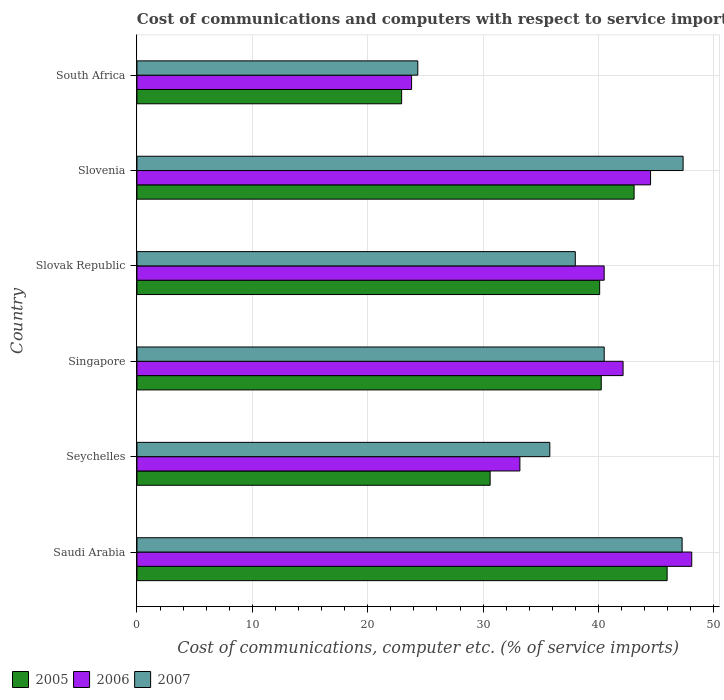How many different coloured bars are there?
Offer a very short reply. 3. What is the label of the 4th group of bars from the top?
Give a very brief answer. Singapore. In how many cases, is the number of bars for a given country not equal to the number of legend labels?
Offer a terse response. 0. What is the cost of communications and computers in 2006 in Slovak Republic?
Ensure brevity in your answer.  40.49. Across all countries, what is the maximum cost of communications and computers in 2007?
Offer a terse response. 47.33. Across all countries, what is the minimum cost of communications and computers in 2007?
Ensure brevity in your answer.  24.34. In which country was the cost of communications and computers in 2007 maximum?
Offer a terse response. Slovenia. In which country was the cost of communications and computers in 2005 minimum?
Make the answer very short. South Africa. What is the total cost of communications and computers in 2007 in the graph?
Ensure brevity in your answer.  233.18. What is the difference between the cost of communications and computers in 2005 in Saudi Arabia and that in Slovenia?
Your answer should be very brief. 2.86. What is the difference between the cost of communications and computers in 2007 in Slovak Republic and the cost of communications and computers in 2005 in Slovenia?
Ensure brevity in your answer.  -5.1. What is the average cost of communications and computers in 2006 per country?
Provide a short and direct response. 38.7. What is the difference between the cost of communications and computers in 2007 and cost of communications and computers in 2005 in South Africa?
Give a very brief answer. 1.4. What is the ratio of the cost of communications and computers in 2006 in Seychelles to that in Slovenia?
Provide a succinct answer. 0.75. Is the cost of communications and computers in 2007 in Singapore less than that in Slovak Republic?
Give a very brief answer. No. Is the difference between the cost of communications and computers in 2007 in Singapore and South Africa greater than the difference between the cost of communications and computers in 2005 in Singapore and South Africa?
Offer a very short reply. No. What is the difference between the highest and the second highest cost of communications and computers in 2005?
Your answer should be compact. 2.86. What is the difference between the highest and the lowest cost of communications and computers in 2005?
Keep it short and to the point. 23.01. What does the 3rd bar from the bottom in Slovenia represents?
Your answer should be very brief. 2007. Is it the case that in every country, the sum of the cost of communications and computers in 2007 and cost of communications and computers in 2006 is greater than the cost of communications and computers in 2005?
Your answer should be compact. Yes. Are all the bars in the graph horizontal?
Give a very brief answer. Yes. What is the difference between two consecutive major ticks on the X-axis?
Your answer should be compact. 10. Are the values on the major ticks of X-axis written in scientific E-notation?
Offer a terse response. No. Does the graph contain any zero values?
Offer a terse response. No. Does the graph contain grids?
Ensure brevity in your answer.  Yes. How many legend labels are there?
Keep it short and to the point. 3. How are the legend labels stacked?
Your response must be concise. Horizontal. What is the title of the graph?
Provide a short and direct response. Cost of communications and computers with respect to service imports. Does "1991" appear as one of the legend labels in the graph?
Keep it short and to the point. No. What is the label or title of the X-axis?
Offer a terse response. Cost of communications, computer etc. (% of service imports). What is the label or title of the Y-axis?
Give a very brief answer. Country. What is the Cost of communications, computer etc. (% of service imports) of 2005 in Saudi Arabia?
Give a very brief answer. 45.95. What is the Cost of communications, computer etc. (% of service imports) in 2006 in Saudi Arabia?
Make the answer very short. 48.08. What is the Cost of communications, computer etc. (% of service imports) of 2007 in Saudi Arabia?
Ensure brevity in your answer.  47.25. What is the Cost of communications, computer etc. (% of service imports) of 2005 in Seychelles?
Your answer should be compact. 30.61. What is the Cost of communications, computer etc. (% of service imports) of 2006 in Seychelles?
Provide a short and direct response. 33.19. What is the Cost of communications, computer etc. (% of service imports) of 2007 in Seychelles?
Your answer should be very brief. 35.78. What is the Cost of communications, computer etc. (% of service imports) of 2005 in Singapore?
Your answer should be very brief. 40.24. What is the Cost of communications, computer etc. (% of service imports) in 2006 in Singapore?
Keep it short and to the point. 42.13. What is the Cost of communications, computer etc. (% of service imports) of 2007 in Singapore?
Ensure brevity in your answer.  40.49. What is the Cost of communications, computer etc. (% of service imports) of 2005 in Slovak Republic?
Keep it short and to the point. 40.1. What is the Cost of communications, computer etc. (% of service imports) in 2006 in Slovak Republic?
Provide a short and direct response. 40.49. What is the Cost of communications, computer etc. (% of service imports) in 2007 in Slovak Republic?
Keep it short and to the point. 37.99. What is the Cost of communications, computer etc. (% of service imports) in 2005 in Slovenia?
Provide a succinct answer. 43.08. What is the Cost of communications, computer etc. (% of service imports) in 2006 in Slovenia?
Give a very brief answer. 44.51. What is the Cost of communications, computer etc. (% of service imports) in 2007 in Slovenia?
Keep it short and to the point. 47.33. What is the Cost of communications, computer etc. (% of service imports) in 2005 in South Africa?
Make the answer very short. 22.94. What is the Cost of communications, computer etc. (% of service imports) of 2006 in South Africa?
Provide a succinct answer. 23.8. What is the Cost of communications, computer etc. (% of service imports) in 2007 in South Africa?
Keep it short and to the point. 24.34. Across all countries, what is the maximum Cost of communications, computer etc. (% of service imports) in 2005?
Give a very brief answer. 45.95. Across all countries, what is the maximum Cost of communications, computer etc. (% of service imports) of 2006?
Your answer should be compact. 48.08. Across all countries, what is the maximum Cost of communications, computer etc. (% of service imports) in 2007?
Your response must be concise. 47.33. Across all countries, what is the minimum Cost of communications, computer etc. (% of service imports) of 2005?
Your answer should be very brief. 22.94. Across all countries, what is the minimum Cost of communications, computer etc. (% of service imports) in 2006?
Ensure brevity in your answer.  23.8. Across all countries, what is the minimum Cost of communications, computer etc. (% of service imports) in 2007?
Provide a short and direct response. 24.34. What is the total Cost of communications, computer etc. (% of service imports) in 2005 in the graph?
Offer a very short reply. 222.92. What is the total Cost of communications, computer etc. (% of service imports) of 2006 in the graph?
Offer a very short reply. 232.2. What is the total Cost of communications, computer etc. (% of service imports) of 2007 in the graph?
Ensure brevity in your answer.  233.18. What is the difference between the Cost of communications, computer etc. (% of service imports) of 2005 in Saudi Arabia and that in Seychelles?
Ensure brevity in your answer.  15.34. What is the difference between the Cost of communications, computer etc. (% of service imports) of 2006 in Saudi Arabia and that in Seychelles?
Ensure brevity in your answer.  14.9. What is the difference between the Cost of communications, computer etc. (% of service imports) in 2007 in Saudi Arabia and that in Seychelles?
Provide a succinct answer. 11.47. What is the difference between the Cost of communications, computer etc. (% of service imports) of 2005 in Saudi Arabia and that in Singapore?
Your answer should be compact. 5.71. What is the difference between the Cost of communications, computer etc. (% of service imports) in 2006 in Saudi Arabia and that in Singapore?
Keep it short and to the point. 5.95. What is the difference between the Cost of communications, computer etc. (% of service imports) of 2007 in Saudi Arabia and that in Singapore?
Give a very brief answer. 6.75. What is the difference between the Cost of communications, computer etc. (% of service imports) in 2005 in Saudi Arabia and that in Slovak Republic?
Your response must be concise. 5.85. What is the difference between the Cost of communications, computer etc. (% of service imports) of 2006 in Saudi Arabia and that in Slovak Republic?
Your answer should be very brief. 7.59. What is the difference between the Cost of communications, computer etc. (% of service imports) of 2007 in Saudi Arabia and that in Slovak Republic?
Keep it short and to the point. 9.26. What is the difference between the Cost of communications, computer etc. (% of service imports) of 2005 in Saudi Arabia and that in Slovenia?
Give a very brief answer. 2.86. What is the difference between the Cost of communications, computer etc. (% of service imports) in 2006 in Saudi Arabia and that in Slovenia?
Your answer should be very brief. 3.57. What is the difference between the Cost of communications, computer etc. (% of service imports) of 2007 in Saudi Arabia and that in Slovenia?
Keep it short and to the point. -0.08. What is the difference between the Cost of communications, computer etc. (% of service imports) of 2005 in Saudi Arabia and that in South Africa?
Ensure brevity in your answer.  23.01. What is the difference between the Cost of communications, computer etc. (% of service imports) in 2006 in Saudi Arabia and that in South Africa?
Keep it short and to the point. 24.28. What is the difference between the Cost of communications, computer etc. (% of service imports) of 2007 in Saudi Arabia and that in South Africa?
Your response must be concise. 22.91. What is the difference between the Cost of communications, computer etc. (% of service imports) of 2005 in Seychelles and that in Singapore?
Ensure brevity in your answer.  -9.63. What is the difference between the Cost of communications, computer etc. (% of service imports) of 2006 in Seychelles and that in Singapore?
Your response must be concise. -8.94. What is the difference between the Cost of communications, computer etc. (% of service imports) of 2007 in Seychelles and that in Singapore?
Offer a terse response. -4.71. What is the difference between the Cost of communications, computer etc. (% of service imports) in 2005 in Seychelles and that in Slovak Republic?
Provide a succinct answer. -9.49. What is the difference between the Cost of communications, computer etc. (% of service imports) of 2006 in Seychelles and that in Slovak Republic?
Ensure brevity in your answer.  -7.3. What is the difference between the Cost of communications, computer etc. (% of service imports) of 2007 in Seychelles and that in Slovak Republic?
Provide a short and direct response. -2.21. What is the difference between the Cost of communications, computer etc. (% of service imports) of 2005 in Seychelles and that in Slovenia?
Your answer should be compact. -12.48. What is the difference between the Cost of communications, computer etc. (% of service imports) in 2006 in Seychelles and that in Slovenia?
Give a very brief answer. -11.32. What is the difference between the Cost of communications, computer etc. (% of service imports) in 2007 in Seychelles and that in Slovenia?
Your answer should be compact. -11.55. What is the difference between the Cost of communications, computer etc. (% of service imports) of 2005 in Seychelles and that in South Africa?
Your response must be concise. 7.67. What is the difference between the Cost of communications, computer etc. (% of service imports) of 2006 in Seychelles and that in South Africa?
Give a very brief answer. 9.39. What is the difference between the Cost of communications, computer etc. (% of service imports) of 2007 in Seychelles and that in South Africa?
Offer a terse response. 11.44. What is the difference between the Cost of communications, computer etc. (% of service imports) in 2005 in Singapore and that in Slovak Republic?
Make the answer very short. 0.13. What is the difference between the Cost of communications, computer etc. (% of service imports) of 2006 in Singapore and that in Slovak Republic?
Provide a succinct answer. 1.64. What is the difference between the Cost of communications, computer etc. (% of service imports) in 2007 in Singapore and that in Slovak Republic?
Your answer should be very brief. 2.5. What is the difference between the Cost of communications, computer etc. (% of service imports) of 2005 in Singapore and that in Slovenia?
Your response must be concise. -2.85. What is the difference between the Cost of communications, computer etc. (% of service imports) in 2006 in Singapore and that in Slovenia?
Keep it short and to the point. -2.38. What is the difference between the Cost of communications, computer etc. (% of service imports) of 2007 in Singapore and that in Slovenia?
Make the answer very short. -6.84. What is the difference between the Cost of communications, computer etc. (% of service imports) in 2005 in Singapore and that in South Africa?
Offer a terse response. 17.3. What is the difference between the Cost of communications, computer etc. (% of service imports) in 2006 in Singapore and that in South Africa?
Your answer should be very brief. 18.33. What is the difference between the Cost of communications, computer etc. (% of service imports) of 2007 in Singapore and that in South Africa?
Make the answer very short. 16.16. What is the difference between the Cost of communications, computer etc. (% of service imports) of 2005 in Slovak Republic and that in Slovenia?
Give a very brief answer. -2.98. What is the difference between the Cost of communications, computer etc. (% of service imports) of 2006 in Slovak Republic and that in Slovenia?
Your response must be concise. -4.02. What is the difference between the Cost of communications, computer etc. (% of service imports) of 2007 in Slovak Republic and that in Slovenia?
Keep it short and to the point. -9.34. What is the difference between the Cost of communications, computer etc. (% of service imports) in 2005 in Slovak Republic and that in South Africa?
Offer a terse response. 17.16. What is the difference between the Cost of communications, computer etc. (% of service imports) in 2006 in Slovak Republic and that in South Africa?
Make the answer very short. 16.69. What is the difference between the Cost of communications, computer etc. (% of service imports) of 2007 in Slovak Republic and that in South Africa?
Your response must be concise. 13.65. What is the difference between the Cost of communications, computer etc. (% of service imports) in 2005 in Slovenia and that in South Africa?
Your answer should be very brief. 20.15. What is the difference between the Cost of communications, computer etc. (% of service imports) of 2006 in Slovenia and that in South Africa?
Provide a succinct answer. 20.71. What is the difference between the Cost of communications, computer etc. (% of service imports) in 2007 in Slovenia and that in South Africa?
Your response must be concise. 22.99. What is the difference between the Cost of communications, computer etc. (% of service imports) in 2005 in Saudi Arabia and the Cost of communications, computer etc. (% of service imports) in 2006 in Seychelles?
Your answer should be very brief. 12.76. What is the difference between the Cost of communications, computer etc. (% of service imports) of 2005 in Saudi Arabia and the Cost of communications, computer etc. (% of service imports) of 2007 in Seychelles?
Offer a terse response. 10.17. What is the difference between the Cost of communications, computer etc. (% of service imports) in 2006 in Saudi Arabia and the Cost of communications, computer etc. (% of service imports) in 2007 in Seychelles?
Keep it short and to the point. 12.3. What is the difference between the Cost of communications, computer etc. (% of service imports) of 2005 in Saudi Arabia and the Cost of communications, computer etc. (% of service imports) of 2006 in Singapore?
Keep it short and to the point. 3.82. What is the difference between the Cost of communications, computer etc. (% of service imports) of 2005 in Saudi Arabia and the Cost of communications, computer etc. (% of service imports) of 2007 in Singapore?
Provide a succinct answer. 5.45. What is the difference between the Cost of communications, computer etc. (% of service imports) in 2006 in Saudi Arabia and the Cost of communications, computer etc. (% of service imports) in 2007 in Singapore?
Your response must be concise. 7.59. What is the difference between the Cost of communications, computer etc. (% of service imports) of 2005 in Saudi Arabia and the Cost of communications, computer etc. (% of service imports) of 2006 in Slovak Republic?
Keep it short and to the point. 5.46. What is the difference between the Cost of communications, computer etc. (% of service imports) of 2005 in Saudi Arabia and the Cost of communications, computer etc. (% of service imports) of 2007 in Slovak Republic?
Give a very brief answer. 7.96. What is the difference between the Cost of communications, computer etc. (% of service imports) in 2006 in Saudi Arabia and the Cost of communications, computer etc. (% of service imports) in 2007 in Slovak Republic?
Provide a succinct answer. 10.09. What is the difference between the Cost of communications, computer etc. (% of service imports) in 2005 in Saudi Arabia and the Cost of communications, computer etc. (% of service imports) in 2006 in Slovenia?
Give a very brief answer. 1.44. What is the difference between the Cost of communications, computer etc. (% of service imports) in 2005 in Saudi Arabia and the Cost of communications, computer etc. (% of service imports) in 2007 in Slovenia?
Offer a very short reply. -1.38. What is the difference between the Cost of communications, computer etc. (% of service imports) of 2006 in Saudi Arabia and the Cost of communications, computer etc. (% of service imports) of 2007 in Slovenia?
Offer a terse response. 0.75. What is the difference between the Cost of communications, computer etc. (% of service imports) in 2005 in Saudi Arabia and the Cost of communications, computer etc. (% of service imports) in 2006 in South Africa?
Give a very brief answer. 22.15. What is the difference between the Cost of communications, computer etc. (% of service imports) in 2005 in Saudi Arabia and the Cost of communications, computer etc. (% of service imports) in 2007 in South Africa?
Ensure brevity in your answer.  21.61. What is the difference between the Cost of communications, computer etc. (% of service imports) of 2006 in Saudi Arabia and the Cost of communications, computer etc. (% of service imports) of 2007 in South Africa?
Your answer should be very brief. 23.74. What is the difference between the Cost of communications, computer etc. (% of service imports) in 2005 in Seychelles and the Cost of communications, computer etc. (% of service imports) in 2006 in Singapore?
Your answer should be compact. -11.52. What is the difference between the Cost of communications, computer etc. (% of service imports) in 2005 in Seychelles and the Cost of communications, computer etc. (% of service imports) in 2007 in Singapore?
Your response must be concise. -9.89. What is the difference between the Cost of communications, computer etc. (% of service imports) of 2006 in Seychelles and the Cost of communications, computer etc. (% of service imports) of 2007 in Singapore?
Offer a very short reply. -7.31. What is the difference between the Cost of communications, computer etc. (% of service imports) in 2005 in Seychelles and the Cost of communications, computer etc. (% of service imports) in 2006 in Slovak Republic?
Offer a very short reply. -9.88. What is the difference between the Cost of communications, computer etc. (% of service imports) of 2005 in Seychelles and the Cost of communications, computer etc. (% of service imports) of 2007 in Slovak Republic?
Your answer should be compact. -7.38. What is the difference between the Cost of communications, computer etc. (% of service imports) of 2006 in Seychelles and the Cost of communications, computer etc. (% of service imports) of 2007 in Slovak Republic?
Make the answer very short. -4.8. What is the difference between the Cost of communications, computer etc. (% of service imports) of 2005 in Seychelles and the Cost of communications, computer etc. (% of service imports) of 2006 in Slovenia?
Ensure brevity in your answer.  -13.9. What is the difference between the Cost of communications, computer etc. (% of service imports) in 2005 in Seychelles and the Cost of communications, computer etc. (% of service imports) in 2007 in Slovenia?
Offer a very short reply. -16.72. What is the difference between the Cost of communications, computer etc. (% of service imports) in 2006 in Seychelles and the Cost of communications, computer etc. (% of service imports) in 2007 in Slovenia?
Make the answer very short. -14.14. What is the difference between the Cost of communications, computer etc. (% of service imports) of 2005 in Seychelles and the Cost of communications, computer etc. (% of service imports) of 2006 in South Africa?
Offer a very short reply. 6.81. What is the difference between the Cost of communications, computer etc. (% of service imports) of 2005 in Seychelles and the Cost of communications, computer etc. (% of service imports) of 2007 in South Africa?
Offer a very short reply. 6.27. What is the difference between the Cost of communications, computer etc. (% of service imports) in 2006 in Seychelles and the Cost of communications, computer etc. (% of service imports) in 2007 in South Africa?
Provide a succinct answer. 8.85. What is the difference between the Cost of communications, computer etc. (% of service imports) of 2005 in Singapore and the Cost of communications, computer etc. (% of service imports) of 2006 in Slovak Republic?
Your response must be concise. -0.25. What is the difference between the Cost of communications, computer etc. (% of service imports) in 2005 in Singapore and the Cost of communications, computer etc. (% of service imports) in 2007 in Slovak Republic?
Offer a terse response. 2.25. What is the difference between the Cost of communications, computer etc. (% of service imports) of 2006 in Singapore and the Cost of communications, computer etc. (% of service imports) of 2007 in Slovak Republic?
Your response must be concise. 4.14. What is the difference between the Cost of communications, computer etc. (% of service imports) of 2005 in Singapore and the Cost of communications, computer etc. (% of service imports) of 2006 in Slovenia?
Your answer should be compact. -4.28. What is the difference between the Cost of communications, computer etc. (% of service imports) in 2005 in Singapore and the Cost of communications, computer etc. (% of service imports) in 2007 in Slovenia?
Ensure brevity in your answer.  -7.09. What is the difference between the Cost of communications, computer etc. (% of service imports) of 2006 in Singapore and the Cost of communications, computer etc. (% of service imports) of 2007 in Slovenia?
Your answer should be compact. -5.2. What is the difference between the Cost of communications, computer etc. (% of service imports) of 2005 in Singapore and the Cost of communications, computer etc. (% of service imports) of 2006 in South Africa?
Your answer should be compact. 16.44. What is the difference between the Cost of communications, computer etc. (% of service imports) of 2005 in Singapore and the Cost of communications, computer etc. (% of service imports) of 2007 in South Africa?
Your answer should be very brief. 15.9. What is the difference between the Cost of communications, computer etc. (% of service imports) of 2006 in Singapore and the Cost of communications, computer etc. (% of service imports) of 2007 in South Africa?
Offer a very short reply. 17.79. What is the difference between the Cost of communications, computer etc. (% of service imports) in 2005 in Slovak Republic and the Cost of communications, computer etc. (% of service imports) in 2006 in Slovenia?
Your response must be concise. -4.41. What is the difference between the Cost of communications, computer etc. (% of service imports) in 2005 in Slovak Republic and the Cost of communications, computer etc. (% of service imports) in 2007 in Slovenia?
Offer a very short reply. -7.23. What is the difference between the Cost of communications, computer etc. (% of service imports) of 2006 in Slovak Republic and the Cost of communications, computer etc. (% of service imports) of 2007 in Slovenia?
Your answer should be very brief. -6.84. What is the difference between the Cost of communications, computer etc. (% of service imports) in 2005 in Slovak Republic and the Cost of communications, computer etc. (% of service imports) in 2006 in South Africa?
Your answer should be compact. 16.3. What is the difference between the Cost of communications, computer etc. (% of service imports) in 2005 in Slovak Republic and the Cost of communications, computer etc. (% of service imports) in 2007 in South Africa?
Your answer should be very brief. 15.76. What is the difference between the Cost of communications, computer etc. (% of service imports) in 2006 in Slovak Republic and the Cost of communications, computer etc. (% of service imports) in 2007 in South Africa?
Your answer should be compact. 16.15. What is the difference between the Cost of communications, computer etc. (% of service imports) in 2005 in Slovenia and the Cost of communications, computer etc. (% of service imports) in 2006 in South Africa?
Your answer should be compact. 19.28. What is the difference between the Cost of communications, computer etc. (% of service imports) in 2005 in Slovenia and the Cost of communications, computer etc. (% of service imports) in 2007 in South Africa?
Your answer should be compact. 18.75. What is the difference between the Cost of communications, computer etc. (% of service imports) in 2006 in Slovenia and the Cost of communications, computer etc. (% of service imports) in 2007 in South Africa?
Keep it short and to the point. 20.17. What is the average Cost of communications, computer etc. (% of service imports) in 2005 per country?
Offer a very short reply. 37.15. What is the average Cost of communications, computer etc. (% of service imports) in 2006 per country?
Your answer should be compact. 38.7. What is the average Cost of communications, computer etc. (% of service imports) of 2007 per country?
Your response must be concise. 38.86. What is the difference between the Cost of communications, computer etc. (% of service imports) of 2005 and Cost of communications, computer etc. (% of service imports) of 2006 in Saudi Arabia?
Your answer should be very brief. -2.13. What is the difference between the Cost of communications, computer etc. (% of service imports) in 2005 and Cost of communications, computer etc. (% of service imports) in 2007 in Saudi Arabia?
Ensure brevity in your answer.  -1.3. What is the difference between the Cost of communications, computer etc. (% of service imports) in 2006 and Cost of communications, computer etc. (% of service imports) in 2007 in Saudi Arabia?
Provide a succinct answer. 0.83. What is the difference between the Cost of communications, computer etc. (% of service imports) in 2005 and Cost of communications, computer etc. (% of service imports) in 2006 in Seychelles?
Ensure brevity in your answer.  -2.58. What is the difference between the Cost of communications, computer etc. (% of service imports) of 2005 and Cost of communications, computer etc. (% of service imports) of 2007 in Seychelles?
Keep it short and to the point. -5.17. What is the difference between the Cost of communications, computer etc. (% of service imports) of 2006 and Cost of communications, computer etc. (% of service imports) of 2007 in Seychelles?
Ensure brevity in your answer.  -2.59. What is the difference between the Cost of communications, computer etc. (% of service imports) of 2005 and Cost of communications, computer etc. (% of service imports) of 2006 in Singapore?
Make the answer very short. -1.89. What is the difference between the Cost of communications, computer etc. (% of service imports) of 2005 and Cost of communications, computer etc. (% of service imports) of 2007 in Singapore?
Provide a short and direct response. -0.26. What is the difference between the Cost of communications, computer etc. (% of service imports) of 2006 and Cost of communications, computer etc. (% of service imports) of 2007 in Singapore?
Provide a short and direct response. 1.64. What is the difference between the Cost of communications, computer etc. (% of service imports) of 2005 and Cost of communications, computer etc. (% of service imports) of 2006 in Slovak Republic?
Offer a very short reply. -0.39. What is the difference between the Cost of communications, computer etc. (% of service imports) in 2005 and Cost of communications, computer etc. (% of service imports) in 2007 in Slovak Republic?
Provide a short and direct response. 2.11. What is the difference between the Cost of communications, computer etc. (% of service imports) of 2006 and Cost of communications, computer etc. (% of service imports) of 2007 in Slovak Republic?
Your answer should be compact. 2.5. What is the difference between the Cost of communications, computer etc. (% of service imports) in 2005 and Cost of communications, computer etc. (% of service imports) in 2006 in Slovenia?
Provide a short and direct response. -1.43. What is the difference between the Cost of communications, computer etc. (% of service imports) in 2005 and Cost of communications, computer etc. (% of service imports) in 2007 in Slovenia?
Offer a very short reply. -4.25. What is the difference between the Cost of communications, computer etc. (% of service imports) of 2006 and Cost of communications, computer etc. (% of service imports) of 2007 in Slovenia?
Make the answer very short. -2.82. What is the difference between the Cost of communications, computer etc. (% of service imports) of 2005 and Cost of communications, computer etc. (% of service imports) of 2006 in South Africa?
Ensure brevity in your answer.  -0.86. What is the difference between the Cost of communications, computer etc. (% of service imports) of 2005 and Cost of communications, computer etc. (% of service imports) of 2007 in South Africa?
Your answer should be very brief. -1.4. What is the difference between the Cost of communications, computer etc. (% of service imports) in 2006 and Cost of communications, computer etc. (% of service imports) in 2007 in South Africa?
Your answer should be compact. -0.54. What is the ratio of the Cost of communications, computer etc. (% of service imports) of 2005 in Saudi Arabia to that in Seychelles?
Offer a terse response. 1.5. What is the ratio of the Cost of communications, computer etc. (% of service imports) in 2006 in Saudi Arabia to that in Seychelles?
Make the answer very short. 1.45. What is the ratio of the Cost of communications, computer etc. (% of service imports) in 2007 in Saudi Arabia to that in Seychelles?
Offer a very short reply. 1.32. What is the ratio of the Cost of communications, computer etc. (% of service imports) in 2005 in Saudi Arabia to that in Singapore?
Make the answer very short. 1.14. What is the ratio of the Cost of communications, computer etc. (% of service imports) in 2006 in Saudi Arabia to that in Singapore?
Give a very brief answer. 1.14. What is the ratio of the Cost of communications, computer etc. (% of service imports) in 2007 in Saudi Arabia to that in Singapore?
Offer a terse response. 1.17. What is the ratio of the Cost of communications, computer etc. (% of service imports) of 2005 in Saudi Arabia to that in Slovak Republic?
Your answer should be compact. 1.15. What is the ratio of the Cost of communications, computer etc. (% of service imports) in 2006 in Saudi Arabia to that in Slovak Republic?
Ensure brevity in your answer.  1.19. What is the ratio of the Cost of communications, computer etc. (% of service imports) of 2007 in Saudi Arabia to that in Slovak Republic?
Give a very brief answer. 1.24. What is the ratio of the Cost of communications, computer etc. (% of service imports) in 2005 in Saudi Arabia to that in Slovenia?
Ensure brevity in your answer.  1.07. What is the ratio of the Cost of communications, computer etc. (% of service imports) in 2006 in Saudi Arabia to that in Slovenia?
Your answer should be compact. 1.08. What is the ratio of the Cost of communications, computer etc. (% of service imports) in 2007 in Saudi Arabia to that in Slovenia?
Provide a short and direct response. 1. What is the ratio of the Cost of communications, computer etc. (% of service imports) of 2005 in Saudi Arabia to that in South Africa?
Your response must be concise. 2. What is the ratio of the Cost of communications, computer etc. (% of service imports) in 2006 in Saudi Arabia to that in South Africa?
Make the answer very short. 2.02. What is the ratio of the Cost of communications, computer etc. (% of service imports) of 2007 in Saudi Arabia to that in South Africa?
Make the answer very short. 1.94. What is the ratio of the Cost of communications, computer etc. (% of service imports) in 2005 in Seychelles to that in Singapore?
Offer a very short reply. 0.76. What is the ratio of the Cost of communications, computer etc. (% of service imports) of 2006 in Seychelles to that in Singapore?
Provide a succinct answer. 0.79. What is the ratio of the Cost of communications, computer etc. (% of service imports) in 2007 in Seychelles to that in Singapore?
Provide a succinct answer. 0.88. What is the ratio of the Cost of communications, computer etc. (% of service imports) of 2005 in Seychelles to that in Slovak Republic?
Give a very brief answer. 0.76. What is the ratio of the Cost of communications, computer etc. (% of service imports) in 2006 in Seychelles to that in Slovak Republic?
Offer a terse response. 0.82. What is the ratio of the Cost of communications, computer etc. (% of service imports) of 2007 in Seychelles to that in Slovak Republic?
Your answer should be compact. 0.94. What is the ratio of the Cost of communications, computer etc. (% of service imports) of 2005 in Seychelles to that in Slovenia?
Your response must be concise. 0.71. What is the ratio of the Cost of communications, computer etc. (% of service imports) of 2006 in Seychelles to that in Slovenia?
Your answer should be very brief. 0.75. What is the ratio of the Cost of communications, computer etc. (% of service imports) of 2007 in Seychelles to that in Slovenia?
Offer a terse response. 0.76. What is the ratio of the Cost of communications, computer etc. (% of service imports) of 2005 in Seychelles to that in South Africa?
Offer a very short reply. 1.33. What is the ratio of the Cost of communications, computer etc. (% of service imports) of 2006 in Seychelles to that in South Africa?
Your answer should be compact. 1.39. What is the ratio of the Cost of communications, computer etc. (% of service imports) of 2007 in Seychelles to that in South Africa?
Make the answer very short. 1.47. What is the ratio of the Cost of communications, computer etc. (% of service imports) of 2006 in Singapore to that in Slovak Republic?
Provide a short and direct response. 1.04. What is the ratio of the Cost of communications, computer etc. (% of service imports) in 2007 in Singapore to that in Slovak Republic?
Offer a terse response. 1.07. What is the ratio of the Cost of communications, computer etc. (% of service imports) in 2005 in Singapore to that in Slovenia?
Offer a very short reply. 0.93. What is the ratio of the Cost of communications, computer etc. (% of service imports) of 2006 in Singapore to that in Slovenia?
Give a very brief answer. 0.95. What is the ratio of the Cost of communications, computer etc. (% of service imports) of 2007 in Singapore to that in Slovenia?
Provide a short and direct response. 0.86. What is the ratio of the Cost of communications, computer etc. (% of service imports) in 2005 in Singapore to that in South Africa?
Provide a succinct answer. 1.75. What is the ratio of the Cost of communications, computer etc. (% of service imports) in 2006 in Singapore to that in South Africa?
Offer a terse response. 1.77. What is the ratio of the Cost of communications, computer etc. (% of service imports) in 2007 in Singapore to that in South Africa?
Give a very brief answer. 1.66. What is the ratio of the Cost of communications, computer etc. (% of service imports) of 2005 in Slovak Republic to that in Slovenia?
Provide a succinct answer. 0.93. What is the ratio of the Cost of communications, computer etc. (% of service imports) in 2006 in Slovak Republic to that in Slovenia?
Provide a succinct answer. 0.91. What is the ratio of the Cost of communications, computer etc. (% of service imports) of 2007 in Slovak Republic to that in Slovenia?
Offer a very short reply. 0.8. What is the ratio of the Cost of communications, computer etc. (% of service imports) in 2005 in Slovak Republic to that in South Africa?
Ensure brevity in your answer.  1.75. What is the ratio of the Cost of communications, computer etc. (% of service imports) in 2006 in Slovak Republic to that in South Africa?
Make the answer very short. 1.7. What is the ratio of the Cost of communications, computer etc. (% of service imports) of 2007 in Slovak Republic to that in South Africa?
Your answer should be very brief. 1.56. What is the ratio of the Cost of communications, computer etc. (% of service imports) in 2005 in Slovenia to that in South Africa?
Make the answer very short. 1.88. What is the ratio of the Cost of communications, computer etc. (% of service imports) in 2006 in Slovenia to that in South Africa?
Ensure brevity in your answer.  1.87. What is the ratio of the Cost of communications, computer etc. (% of service imports) of 2007 in Slovenia to that in South Africa?
Offer a terse response. 1.94. What is the difference between the highest and the second highest Cost of communications, computer etc. (% of service imports) of 2005?
Ensure brevity in your answer.  2.86. What is the difference between the highest and the second highest Cost of communications, computer etc. (% of service imports) of 2006?
Provide a succinct answer. 3.57. What is the difference between the highest and the second highest Cost of communications, computer etc. (% of service imports) in 2007?
Offer a very short reply. 0.08. What is the difference between the highest and the lowest Cost of communications, computer etc. (% of service imports) in 2005?
Provide a succinct answer. 23.01. What is the difference between the highest and the lowest Cost of communications, computer etc. (% of service imports) of 2006?
Provide a short and direct response. 24.28. What is the difference between the highest and the lowest Cost of communications, computer etc. (% of service imports) in 2007?
Offer a very short reply. 22.99. 